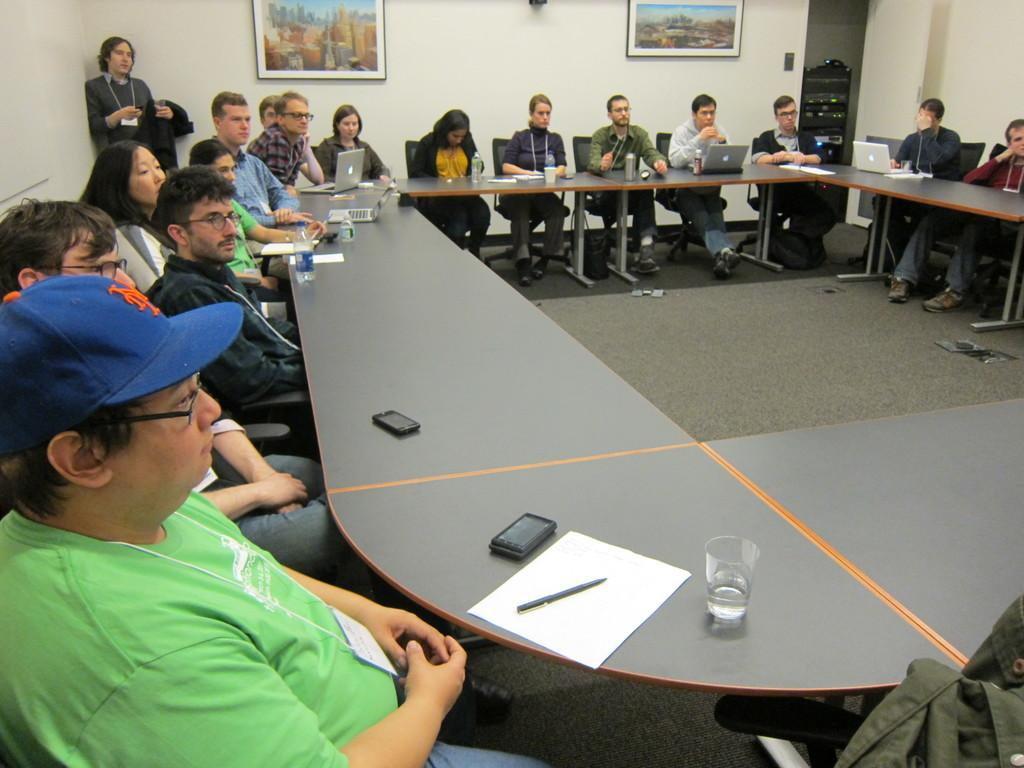What type of room is shown in the image? The image depicts a conference room. What are the people in the room doing? The people are sitting on chairs in the room. How are the chairs arranged in the room? The chairs are arranged in front of a desk. What items can be seen on the desk? There are notes, phones, glasses, and laptops on the desk. What type of ink is being used to write on the sofa in the image? There is no sofa present in the image, and therefore no ink or writing on it. What type of meat is being served on the desk in the image? There is no meat present in the image; the desk contains notes, phones, glasses, and laptops. 